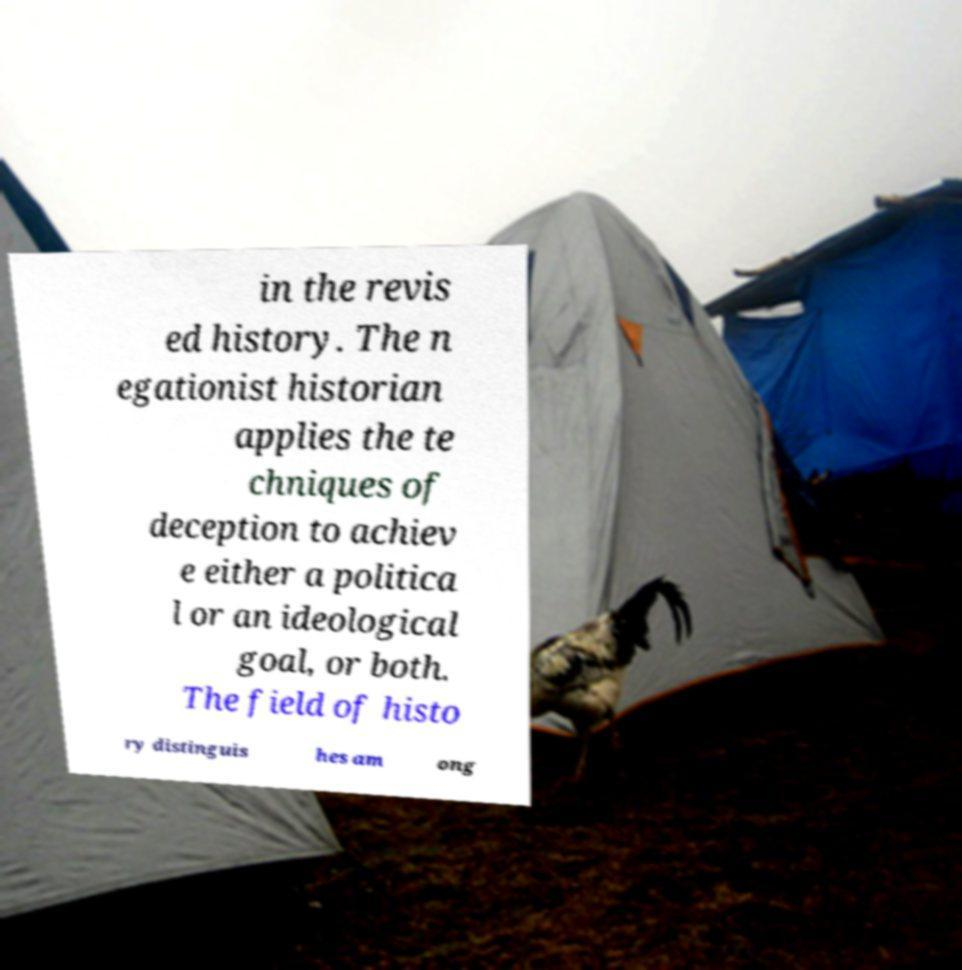Could you extract and type out the text from this image? in the revis ed history. The n egationist historian applies the te chniques of deception to achiev e either a politica l or an ideological goal, or both. The field of histo ry distinguis hes am ong 